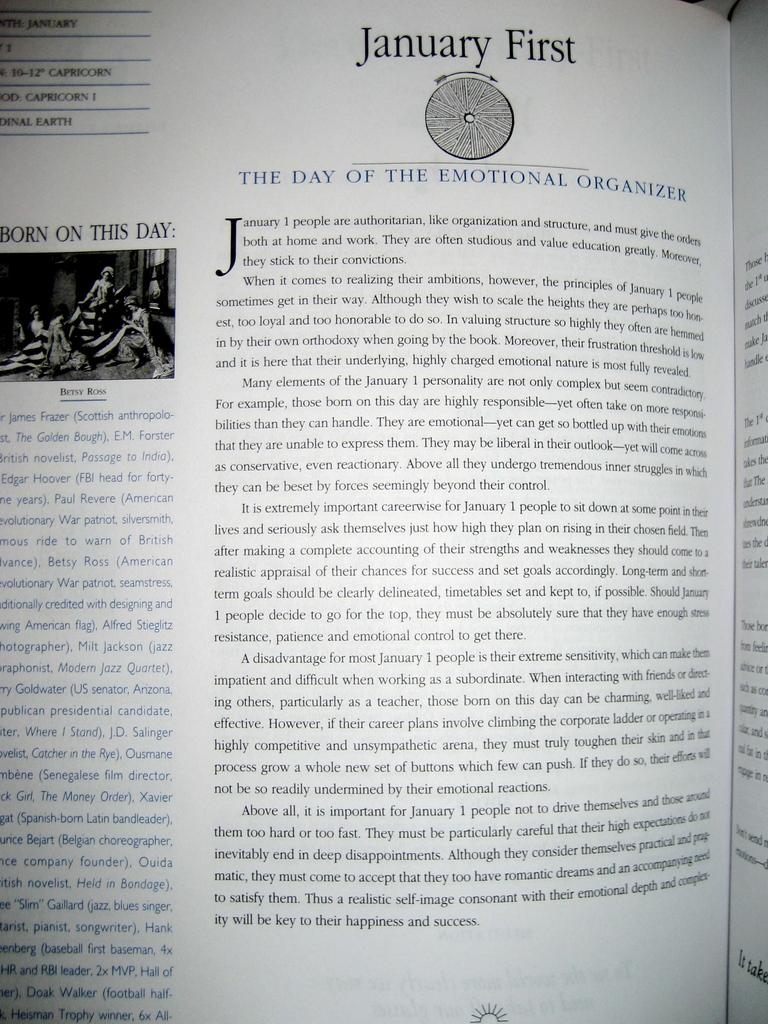Who is pictured with the us flag on the left page?
Ensure brevity in your answer.  Betsy ross. 